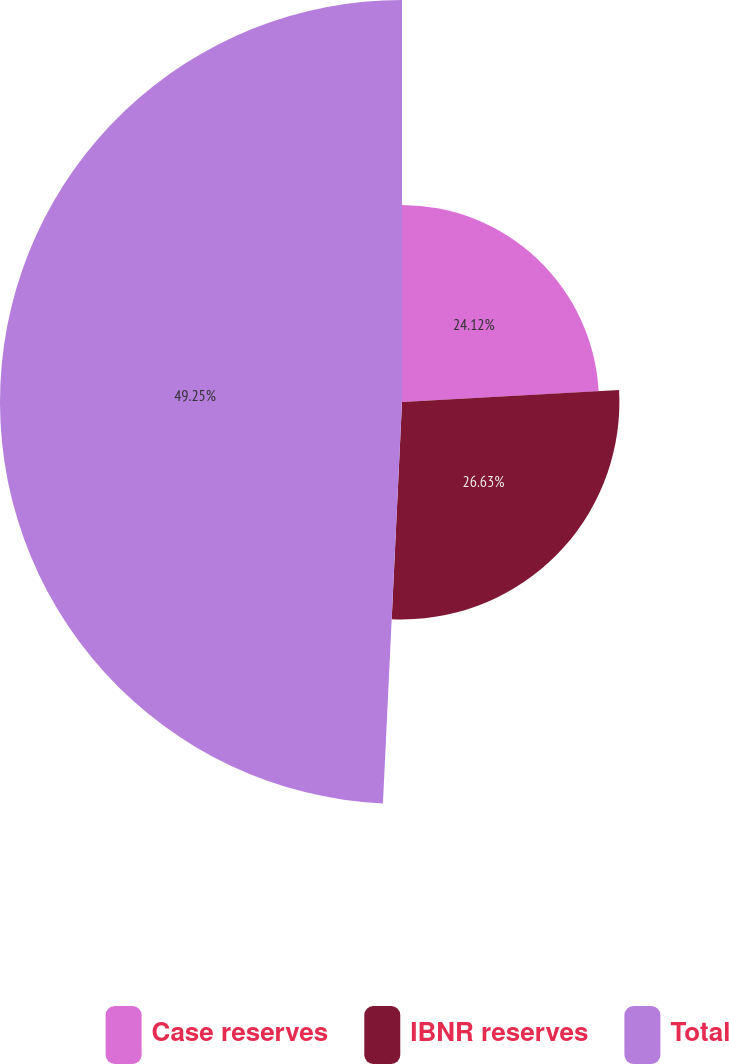Convert chart to OTSL. <chart><loc_0><loc_0><loc_500><loc_500><pie_chart><fcel>Case reserves<fcel>IBNR reserves<fcel>Total<nl><fcel>24.12%<fcel>26.63%<fcel>49.24%<nl></chart> 